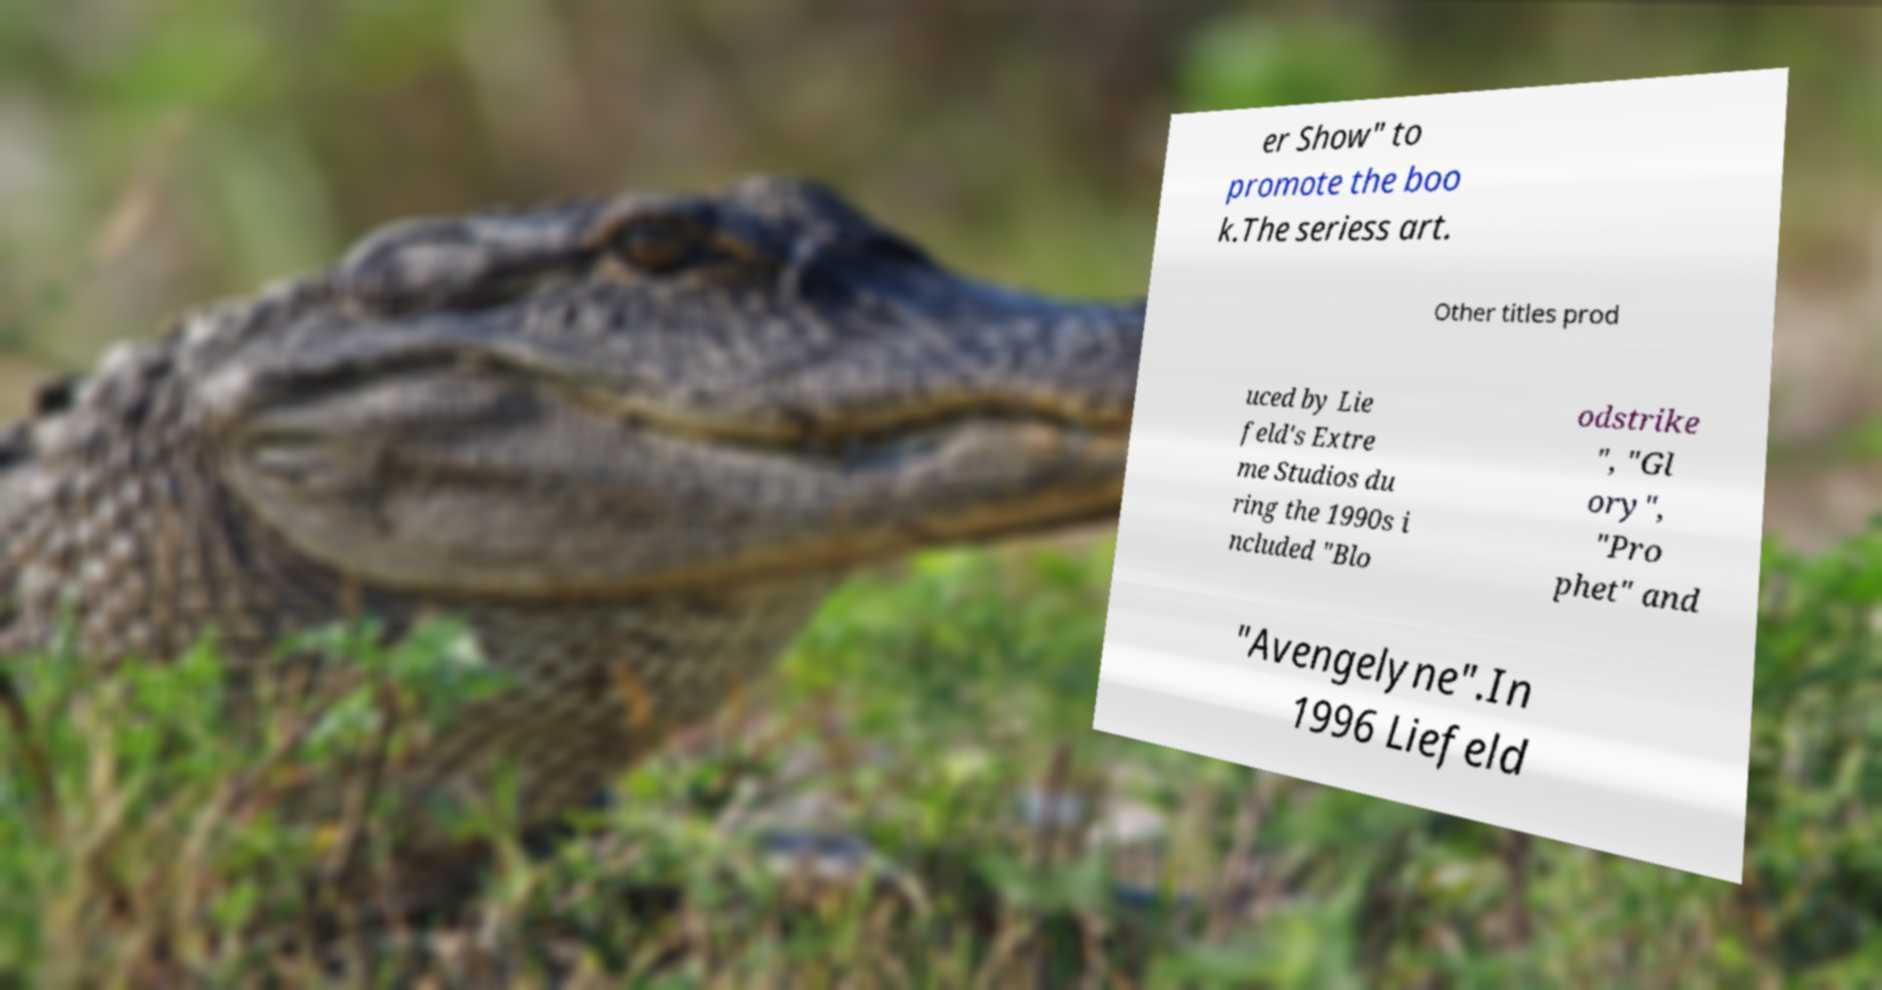Could you extract and type out the text from this image? er Show" to promote the boo k.The seriess art. Other titles prod uced by Lie feld's Extre me Studios du ring the 1990s i ncluded "Blo odstrike ", "Gl ory", "Pro phet" and "Avengelyne".In 1996 Liefeld 